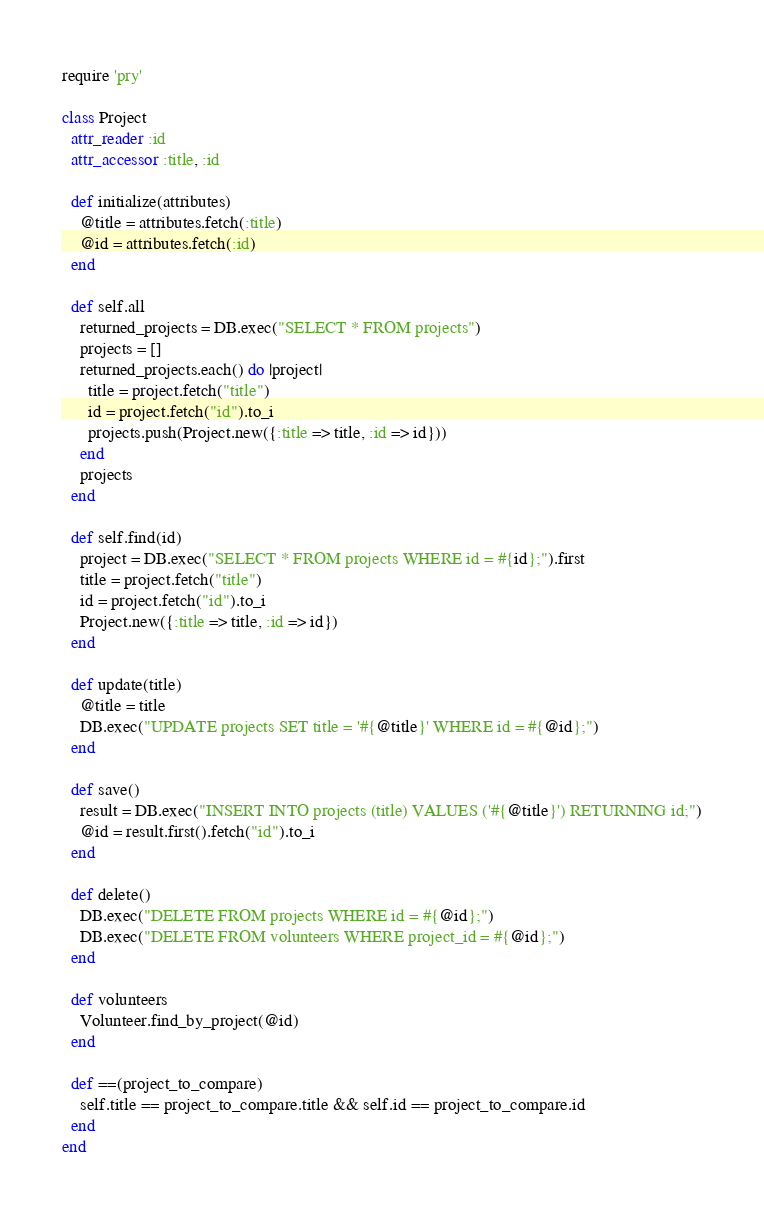<code> <loc_0><loc_0><loc_500><loc_500><_Ruby_>require 'pry'

class Project
  attr_reader :id
  attr_accessor :title, :id
  
  def initialize(attributes)
    @title = attributes.fetch(:title)
    @id = attributes.fetch(:id)
  end
  
  def self.all
    returned_projects = DB.exec("SELECT * FROM projects")
    projects = []
    returned_projects.each() do |project|
      title = project.fetch("title")
      id = project.fetch("id").to_i
      projects.push(Project.new({:title => title, :id => id}))
    end
    projects
  end
  
  def self.find(id)
    project = DB.exec("SELECT * FROM projects WHERE id = #{id};").first
    title = project.fetch("title")
    id = project.fetch("id").to_i
    Project.new({:title => title, :id => id})
  end
  
  def update(title)
    @title = title
    DB.exec("UPDATE projects SET title = '#{@title}' WHERE id = #{@id};")
  end

  def save()
    result = DB.exec("INSERT INTO projects (title) VALUES ('#{@title}') RETURNING id;")
    @id = result.first().fetch("id").to_i
  end

  def delete()
    DB.exec("DELETE FROM projects WHERE id = #{@id};")
    DB.exec("DELETE FROM volunteers WHERE project_id = #{@id};")
  end

  def volunteers
    Volunteer.find_by_project(@id)
  end

  def ==(project_to_compare)
    self.title == project_to_compare.title && self.id == project_to_compare.id
  end
end</code> 